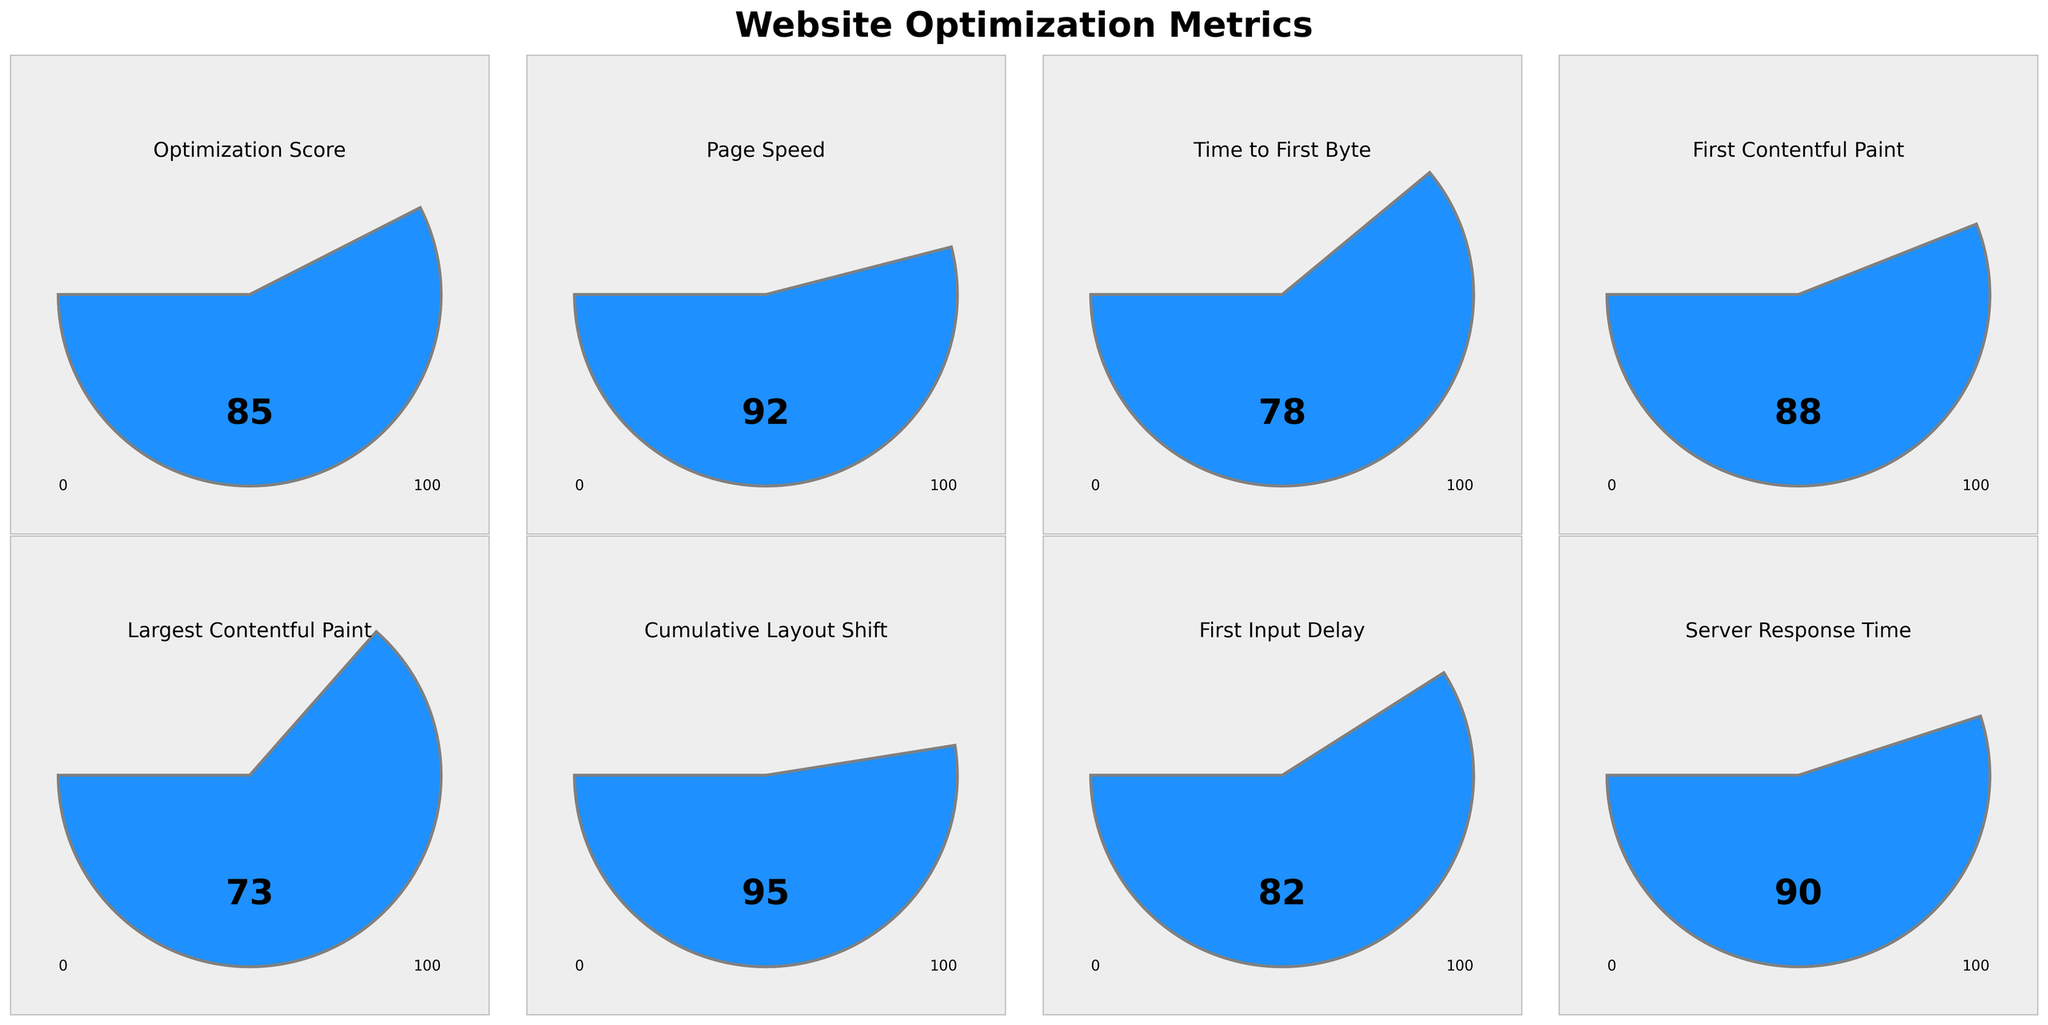What's the title of the figure? The title of the figure is usually placed at the top. In this instance, it can be seen as "Website Optimization Metrics."
Answer: Website Optimization Metrics What is the optimization score? The optimization score can be directly observed in the relevant gauge chart, where the score is displayed as a centered value. Specifically, the value shown for the "Optimization Score" is 85.
Answer: 85 Which metric has the highest score? Scanning through all the gauge charts, we notice the highest score is represented by the "Cumulative Layout Shift," which has a score of 95.
Answer: Cumulative Layout Shift What's the difference between the scores of "Page Speed" and "Server Response Time"? "Page Speed" has a score of 92, and "Server Response Time" has a score of 90. The difference is calculated by subtracting 90 from 92.
Answer: 2 Which metric has the lowest score? Among all the presented metrics, the "Largest Contentful Paint" has the lowest score, as indicated by the score of 73 on its gauge chart.
Answer: Largest Contentful Paint What is the average score of all metrics? Adding all scores together (85 + 92 + 78 + 88 + 73 + 95 + 82 + 90) gives a total of 683. Dividing by the number of metrics (8), we get an average score of 85.375.
Answer: 85.375 How does "Time to First Byte" compare to "First Contentful Paint"? "Time to First Byte" has a score of 78, while "First Contentful Paint" has a score of 88. Comparing these, the "First Contentful Paint" score is higher by 10 points.
Answer: First Contentful Paint is higher Which two metrics have scores closest to each other? Comparing the values visually, "First Input Delay" with a score of 82 and "Server Response Time" with a score of 90 are the closest, with just an 8-point difference.
Answer: First Input Delay and Server Response Time What percentage of the maximum score is the "Optimization Score"? The "Optimization Score" is 85 out of a maximum possible score of 100. The percentage is calculated as (85 / 100) * 100 = 85%.
Answer: 85% Which metric has the largest difference from the "Optimization Score"? To find this, compute the absolute difference between 85 and each metric. The largest difference is with "Largest Contentful Paint" (85 - 73 = 12).
Answer: Largest Contentful Paint 